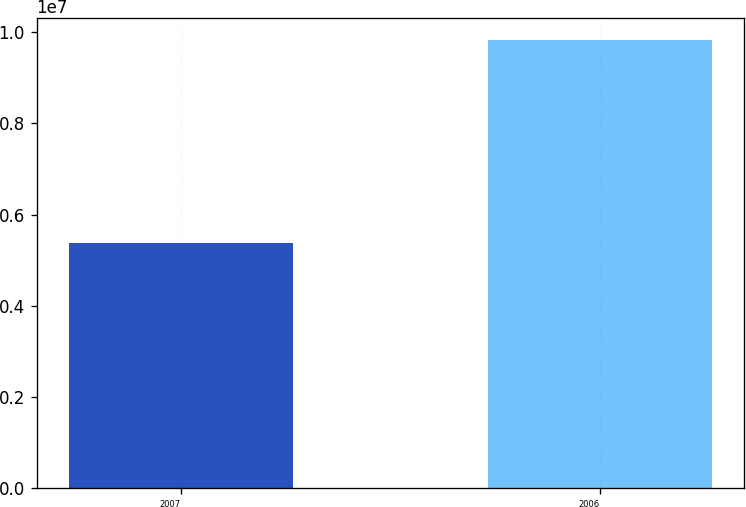Convert chart. <chart><loc_0><loc_0><loc_500><loc_500><bar_chart><fcel>2007<fcel>2006<nl><fcel>5.37954e+06<fcel>9.81849e+06<nl></chart> 